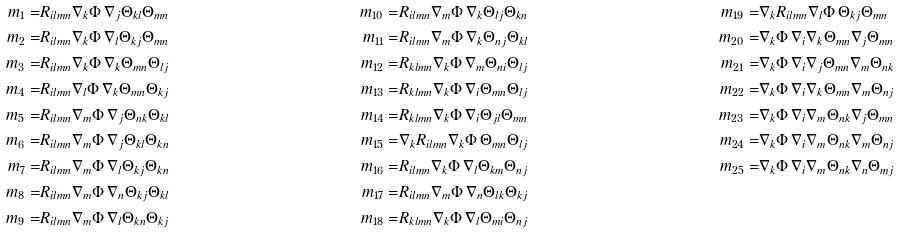Convert formula to latex. <formula><loc_0><loc_0><loc_500><loc_500>m _ { 1 } = & R _ { i l m n } \nabla _ { k } \Phi \, \nabla _ { j } \Theta _ { k l } \Theta _ { m n } & m _ { 1 0 } = & R _ { i l m n } \nabla _ { m } \Phi \, \nabla _ { k } \Theta _ { l j } \Theta _ { k n } & m _ { 1 9 } = & \nabla _ { k } R _ { i l m n } \nabla _ { l } \Phi \, \Theta _ { k j } \Theta _ { m n } \\ m _ { 2 } = & R _ { i l m n } \nabla _ { k } \Phi \, \nabla _ { l } \Theta _ { k j } \Theta _ { m n } & m _ { 1 1 } = & R _ { i l m n } \nabla _ { m } \Phi \, \nabla _ { k } \Theta _ { n j } \Theta _ { k l } & m _ { 2 0 } = & \nabla _ { k } \Phi \, \nabla _ { i } \nabla _ { k } \Theta _ { m n } \nabla _ { j } \Theta _ { m n } \\ m _ { 3 } = & R _ { i l m n } \nabla _ { k } \Phi \, \nabla _ { k } \Theta _ { m n } \Theta _ { l j } & m _ { 1 2 } = & R _ { k l m n } \nabla _ { k } \Phi \, \nabla _ { m } \Theta _ { n i } \Theta _ { l j } & m _ { 2 1 } = & \nabla _ { k } \Phi \, \nabla _ { i } \nabla _ { j } \Theta _ { m n } \nabla _ { m } \Theta _ { n k } \\ m _ { 4 } = & R _ { i l m n } \nabla _ { l } \Phi \, \nabla _ { k } \Theta _ { m n } \Theta _ { k j } & m _ { 1 3 } = & R _ { k l m n } \nabla _ { k } \Phi \, \nabla _ { i } \Theta _ { m n } \Theta _ { l j } & m _ { 2 2 } = & \nabla _ { k } \Phi \, \nabla _ { i } \nabla _ { k } \Theta _ { m n } \nabla _ { m } \Theta _ { n j } \\ m _ { 5 } = & R _ { i l m n } \nabla _ { m } \Phi \, \nabla _ { j } \Theta _ { n k } \Theta _ { k l } & m _ { 1 4 } = & R _ { k l m n } \nabla _ { k } \Phi \, \nabla _ { i } \Theta _ { j l } \Theta _ { m n } & m _ { 2 3 } = & \nabla _ { k } \Phi \, \nabla _ { i } \nabla _ { m } \Theta _ { n k } \nabla _ { j } \Theta _ { m n } \\ m _ { 6 } = & R _ { i l m n } \nabla _ { m } \Phi \, \nabla _ { j } \Theta _ { k l } \Theta _ { k n } & m _ { 1 5 } = & \nabla _ { k } R _ { i l m n } \nabla _ { k } \Phi \, \Theta _ { m n } \Theta _ { l j } & m _ { 2 4 } = & \nabla _ { k } \Phi \, \nabla _ { i } \nabla _ { m } \Theta _ { n k } \nabla _ { m } \Theta _ { n j } \\ m _ { 7 } = & R _ { i l m n } \nabla _ { m } \Phi \, \nabla _ { l } \Theta _ { k j } \Theta _ { k n } & m _ { 1 6 } = & R _ { i l m n } \nabla _ { k } \Phi \, \nabla _ { l } \Theta _ { k m } \Theta _ { n j } & m _ { 2 5 } = & \nabla _ { k } \Phi \, \nabla _ { i } \nabla _ { m } \Theta _ { n k } \nabla _ { n } \Theta _ { m j } \\ m _ { 8 } = & R _ { i l m n } \nabla _ { m } \Phi \, \nabla _ { n } \Theta _ { k j } \Theta _ { k l } & m _ { 1 7 } = & R _ { i l m n } \nabla _ { m } \Phi \, \nabla _ { n } \Theta _ { l k } \Theta _ { k j } \\ m _ { 9 } = & R _ { i l m n } \nabla _ { m } \Phi \, \nabla _ { l } \Theta _ { k n } \Theta _ { k j } & m _ { 1 8 } = & R _ { k l m n } \nabla _ { k } \Phi \, \nabla _ { l } \Theta _ { m i } \Theta _ { n j }</formula> 